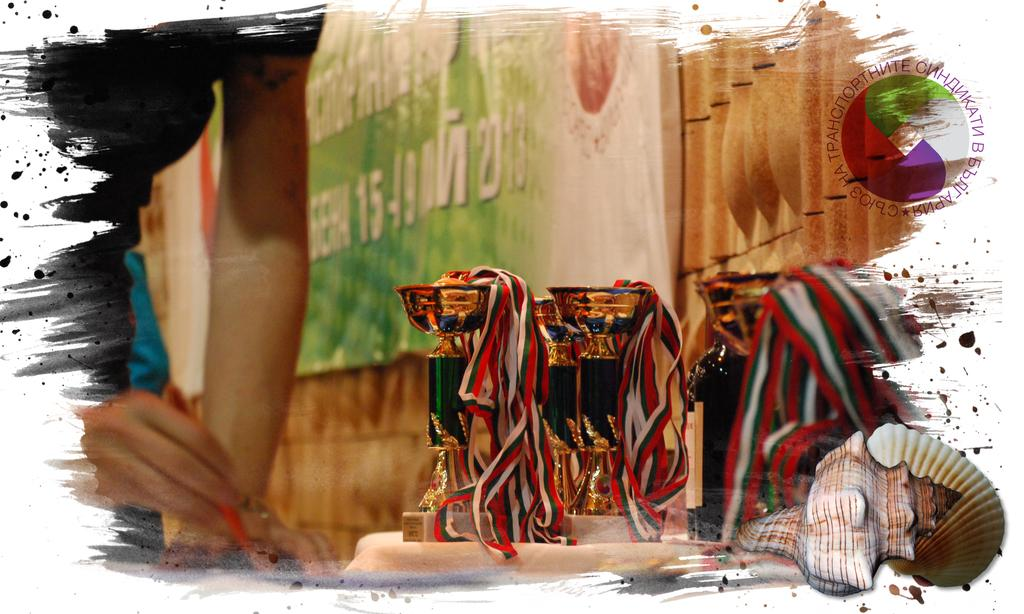What can be seen in the picture that represents an achievement or victory? There are trophies in the picture. What is the person holding in the picture? There is a person holding an object in the picture. What message or information is conveyed by the banner in the picture? There is a banner with writing in the picture. Can you describe any other objects present in the picture? There are other objects present in the picture. What type of battle is depicted in the picture? There is no battle depicted in the picture; it features trophies, a person holding an object, a banner with writing, and other objects. Can you describe the woman in the picture? There is no woman present in the picture. 